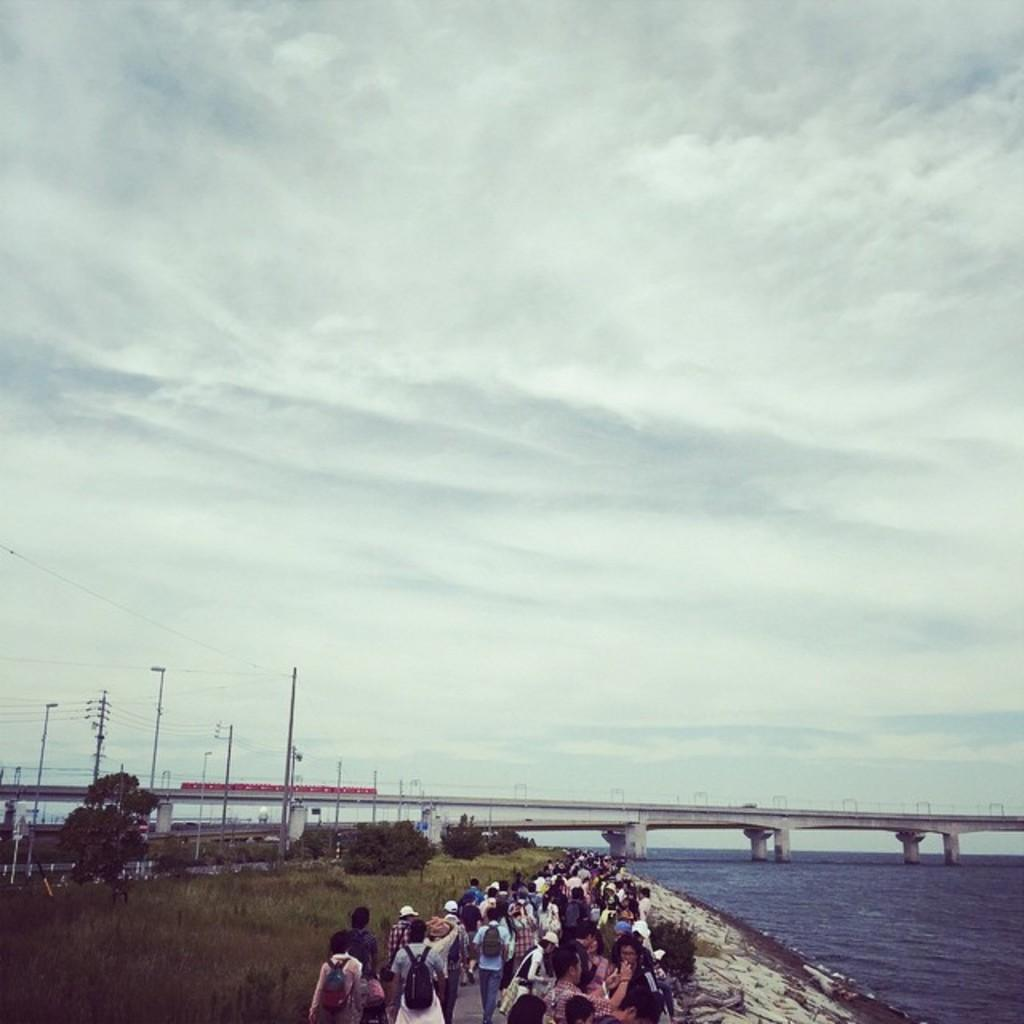What are the people in the image doing? The people in the image are walking on the road. What type of vegetation can be seen in the image? Grass is visible in the image. What architectural feature is present in the image? There is a bridge over a river in the image. What infrastructure elements are visible in the image? Electric poles and electric cables are present in the image. What type of natural environment is visible in the image? Trees are present in the image. What part of the natural environment is visible in the image? The sky is visible in the image, and clouds are present in the sky. What type of education is being provided in the image? There is no indication of education being provided in the image. What type of sofa can be seen in the image? There is no sofa present in the image. 